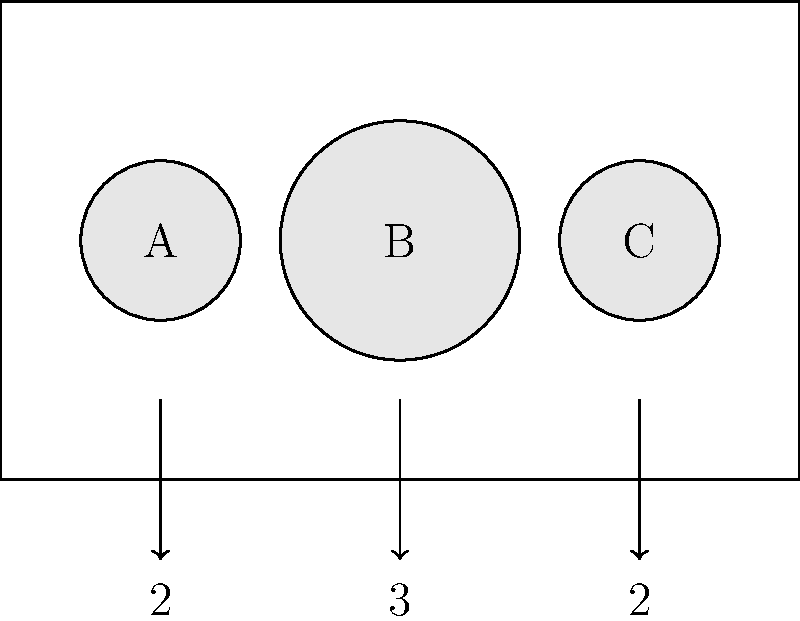You're arranging vases on a rectangular table for a wedding centerpiece. The table is 10 units long, and you have three vases of different sizes: two small vases (A and C) with a diameter of 2 units each, and one large vase (B) with a diameter of 3 units. What is the maximum distance possible between the centers of the two small vases while keeping all vases on the table and maintaining symmetry? To solve this problem, let's follow these steps:

1. Understand the constraints:
   - The table is 10 units long
   - Vase A and C have a diameter of 2 units each
   - Vase B has a diameter of 3 units
   - The arrangement must be symmetrical

2. Calculate the space needed for the vases:
   - Total space for vases = 2 + 3 + 2 = 7 units

3. Calculate the remaining space:
   - Remaining space = Table length - Total space for vases
   - Remaining space = 10 - 7 = 3 units

4. Distribute the remaining space:
   - For symmetry, we need to divide the remaining space equally on both sides of the central vase and between the vases
   - Space on each side = 3 ÷ 3 = 1 unit

5. Calculate the distance between the centers of the small vases:
   - Distance = Table length - (Radius of A + Radius of C)
   - Distance = 10 - (1 + 1) = 8 units

Therefore, the maximum distance possible between the centers of the two small vases while keeping all vases on the table and maintaining symmetry is 8 units.
Answer: 8 units 